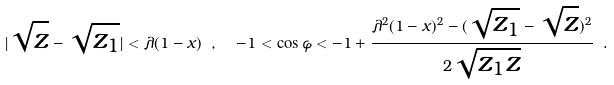Convert formula to latex. <formula><loc_0><loc_0><loc_500><loc_500>| \sqrt { z } - \sqrt { z _ { 1 } } | < \lambda ( 1 - x ) \ , \ \ - 1 < \cos \varphi < - 1 + \frac { \lambda ^ { 2 } ( 1 - x ) ^ { 2 } - ( \sqrt { z _ { 1 } } - \sqrt { z } ) ^ { 2 } } { 2 \sqrt { z _ { 1 } z } } \ .</formula> 